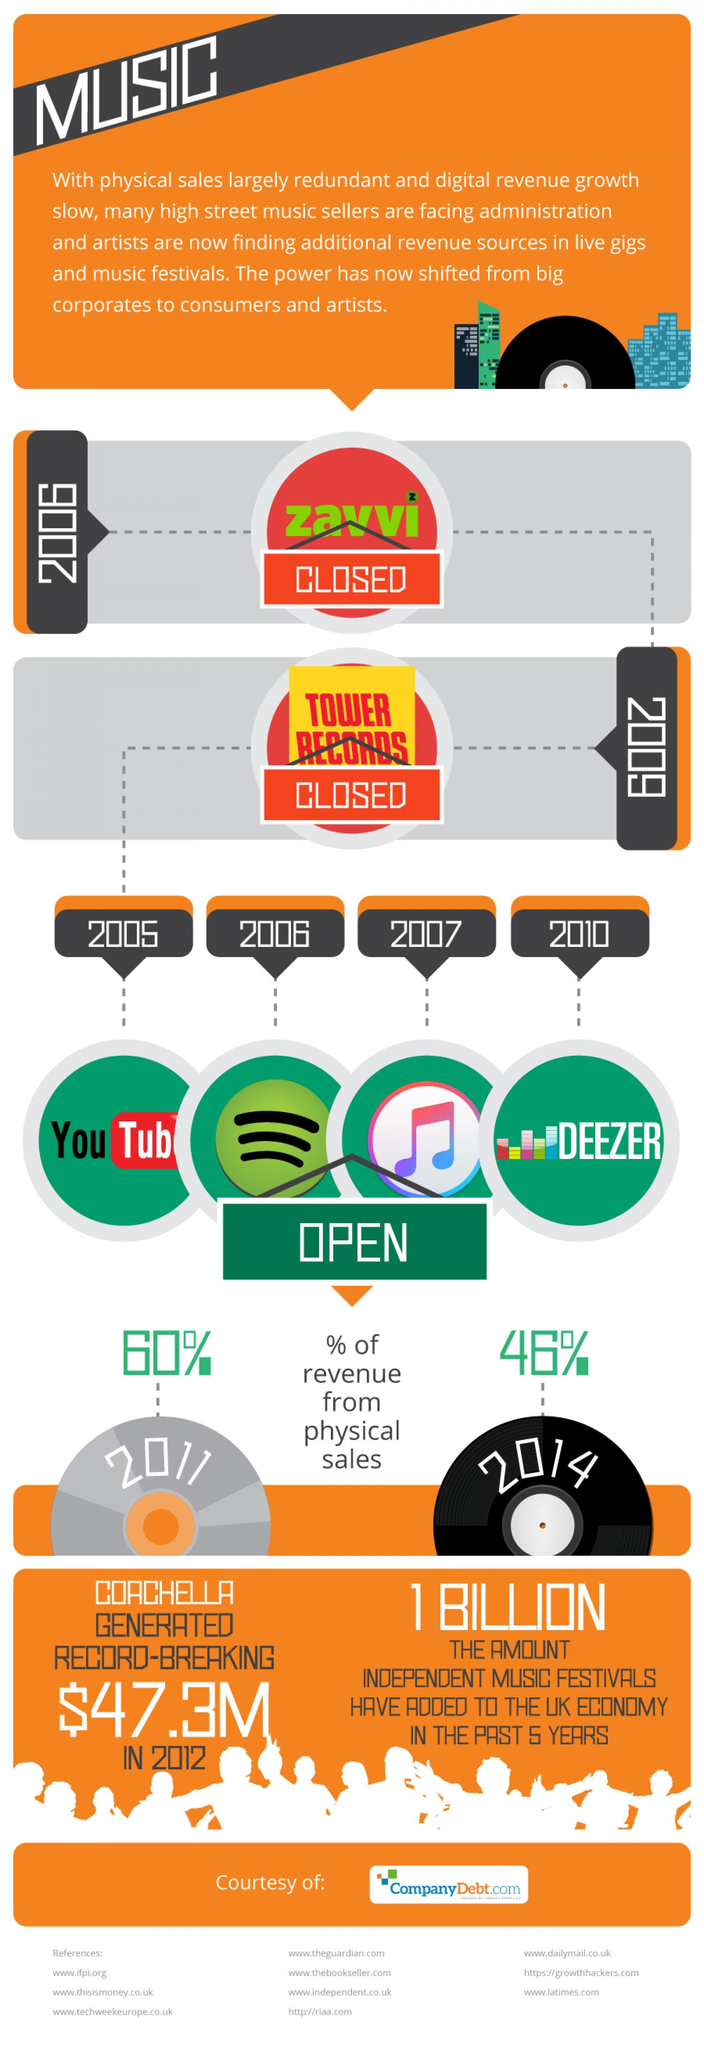Identify some key points in this picture. Between the period of 2006-2009, several music sellers, including Zavvi and Tower Records, shut down their operations. In 2009, Tower Records, a music seller, was closed. During the period of 2011 to 2014, there was a 14% reduction in physical sales. In the year 2006, the music retailer Zavvi was closed. Spotify opened its online music streaming service in 2006, and it has since become one of the leading platforms in the industry. 